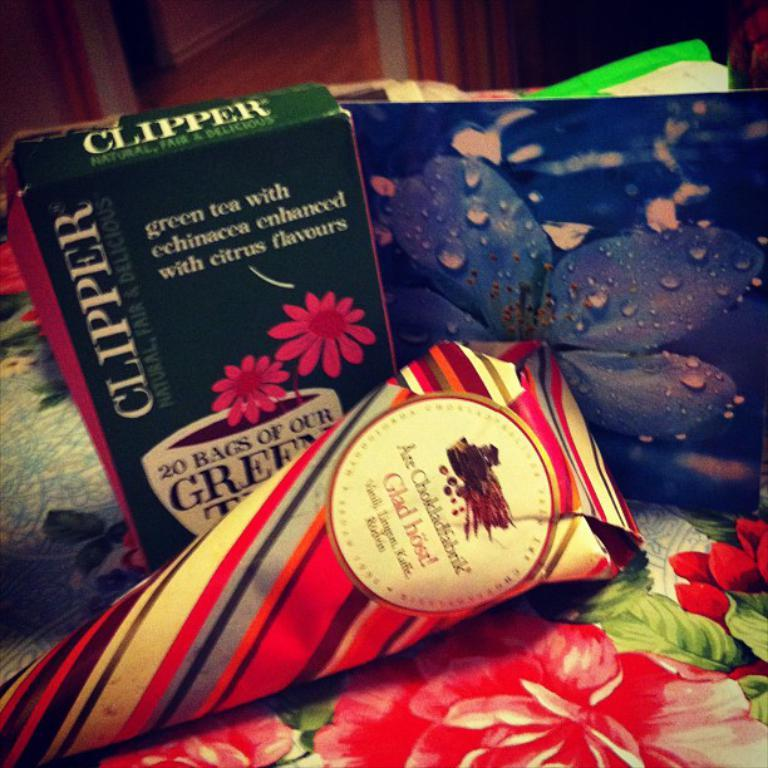<image>
Create a compact narrative representing the image presented. A box of green tea sits with colorful patterned papers. 